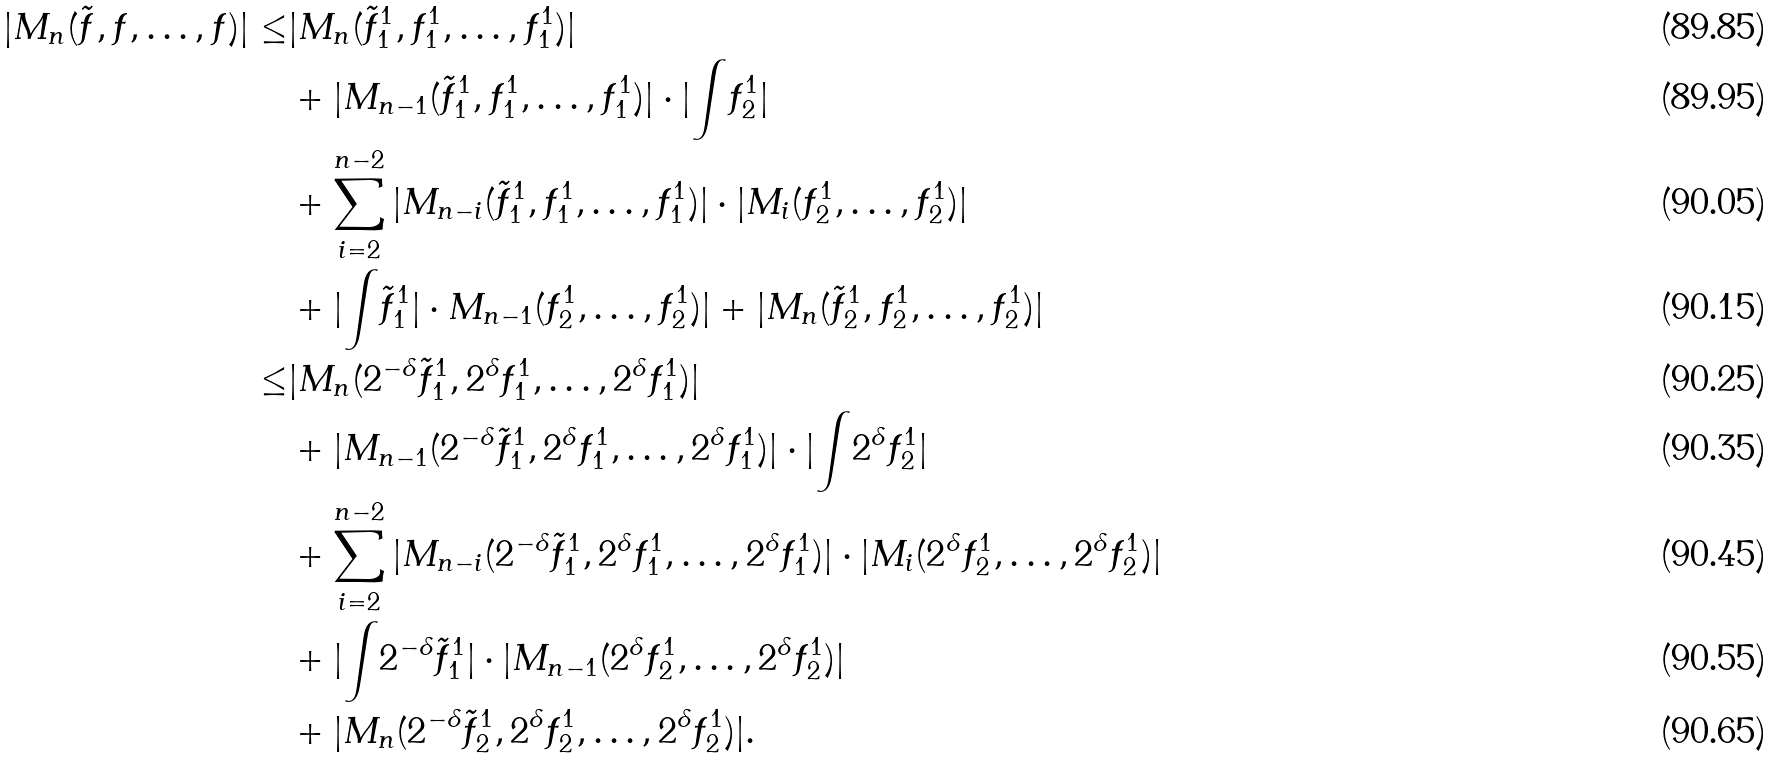<formula> <loc_0><loc_0><loc_500><loc_500>| M _ { n } ( \tilde { f } , f , \dots , f ) | \leq & | M _ { n } ( \tilde { f } ^ { 1 } _ { 1 } , f ^ { 1 } _ { 1 } , \dots , f ^ { 1 } _ { 1 } ) | \\ & + | M _ { n - 1 } ( \tilde { f } ^ { 1 } _ { 1 } , f ^ { 1 } _ { 1 } , \dots , f ^ { 1 } _ { 1 } ) | \cdot | { \int } f ^ { 1 } _ { 2 } | \\ & + \sum _ { i = 2 } ^ { n - 2 } | M _ { n - i } ( \tilde { f } ^ { 1 } _ { 1 } , f ^ { 1 } _ { 1 } , \dots , f ^ { 1 } _ { 1 } ) | \cdot | M _ { i } ( f ^ { 1 } _ { 2 } , \dots , f ^ { 1 } _ { 2 } ) | \\ & + | { \int } \tilde { f } ^ { 1 } _ { 1 } | \cdot M _ { n - 1 } ( f ^ { 1 } _ { 2 } , \dots , f ^ { 1 } _ { 2 } ) | + | M _ { n } ( \tilde { f } ^ { 1 } _ { 2 } , f ^ { 1 } _ { 2 } , \dots , f ^ { 1 } _ { 2 } ) | \\ \leq & | M _ { n } ( 2 ^ { - \delta } \tilde { f } ^ { 1 } _ { 1 } , 2 ^ { \delta } f ^ { 1 } _ { 1 } , \dots , 2 ^ { \delta } f ^ { 1 } _ { 1 } ) | \\ & + | M _ { n - 1 } ( 2 ^ { - \delta } \tilde { f } ^ { 1 } _ { 1 } , 2 ^ { \delta } f ^ { 1 } _ { 1 } , \dots , 2 ^ { \delta } f ^ { 1 } _ { 1 } ) | \cdot | { \int } 2 ^ { \delta } f ^ { 1 } _ { 2 } | \\ & + \sum _ { i = 2 } ^ { n - 2 } | M _ { n - i } ( 2 ^ { - \delta } \tilde { f } ^ { 1 } _ { 1 } , 2 ^ { \delta } f ^ { 1 } _ { 1 } , \dots , 2 ^ { \delta } f ^ { 1 } _ { 1 } ) | \cdot | M _ { i } ( 2 ^ { \delta } f ^ { 1 } _ { 2 } , \dots , 2 ^ { \delta } f ^ { 1 } _ { 2 } ) | \\ & + | { \int } 2 ^ { - \delta } \tilde { f } ^ { 1 } _ { 1 } | \cdot | M _ { n - 1 } ( 2 ^ { \delta } f ^ { 1 } _ { 2 } , \dots , 2 ^ { \delta } f ^ { 1 } _ { 2 } ) | \\ & + | M _ { n } ( 2 ^ { - \delta } \tilde { f } ^ { 1 } _ { 2 } , 2 ^ { \delta } f ^ { 1 } _ { 2 } , \dots , 2 ^ { \delta } f ^ { 1 } _ { 2 } ) | .</formula> 